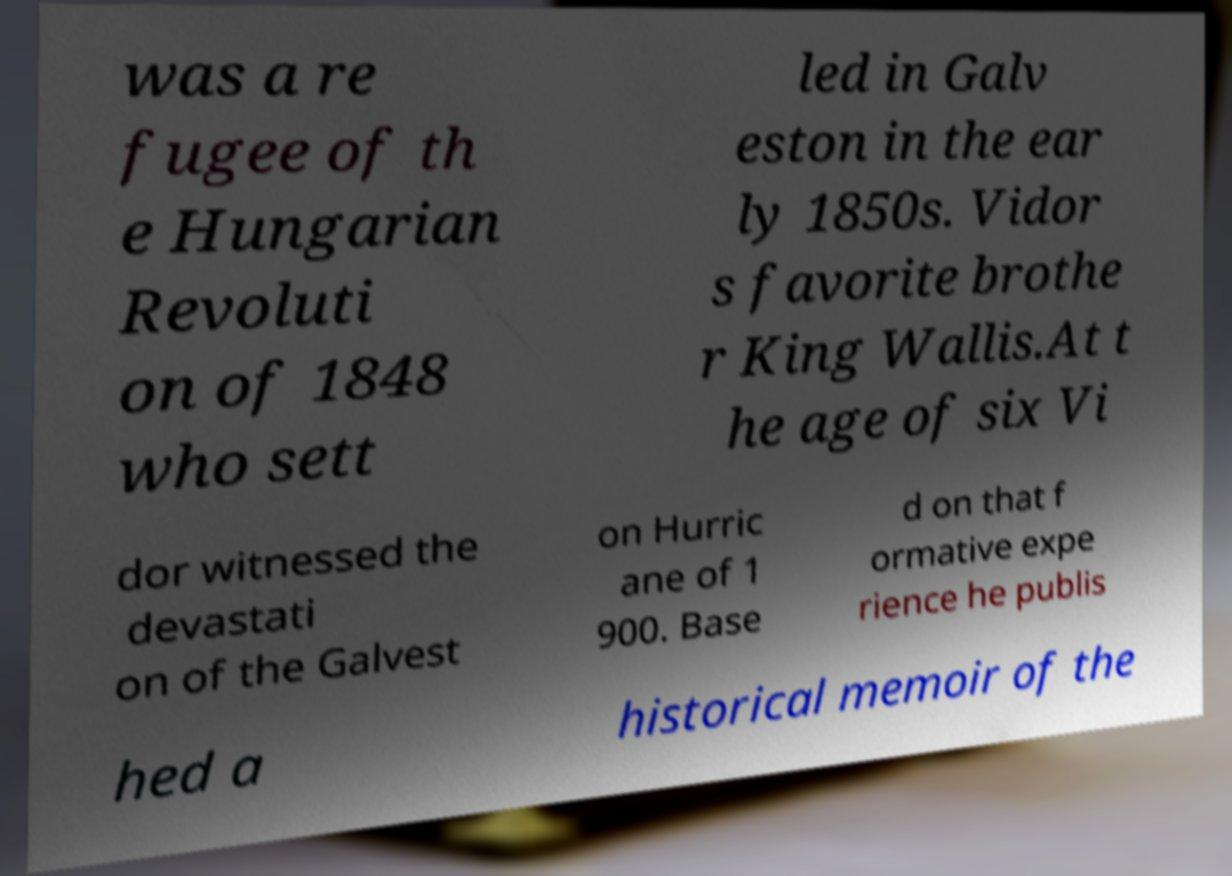Can you accurately transcribe the text from the provided image for me? was a re fugee of th e Hungarian Revoluti on of 1848 who sett led in Galv eston in the ear ly 1850s. Vidor s favorite brothe r King Wallis.At t he age of six Vi dor witnessed the devastati on of the Galvest on Hurric ane of 1 900. Base d on that f ormative expe rience he publis hed a historical memoir of the 